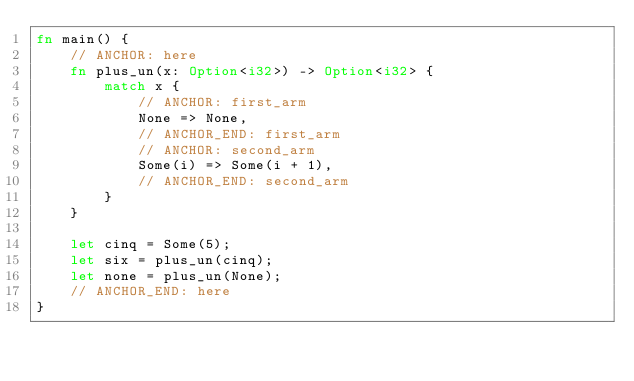<code> <loc_0><loc_0><loc_500><loc_500><_Rust_>fn main() {
    // ANCHOR: here
    fn plus_un(x: Option<i32>) -> Option<i32> {
        match x {
            // ANCHOR: first_arm
            None => None,
            // ANCHOR_END: first_arm
            // ANCHOR: second_arm
            Some(i) => Some(i + 1),
            // ANCHOR_END: second_arm
        }
    }

    let cinq = Some(5);
    let six = plus_un(cinq);
    let none = plus_un(None);
    // ANCHOR_END: here
}
</code> 